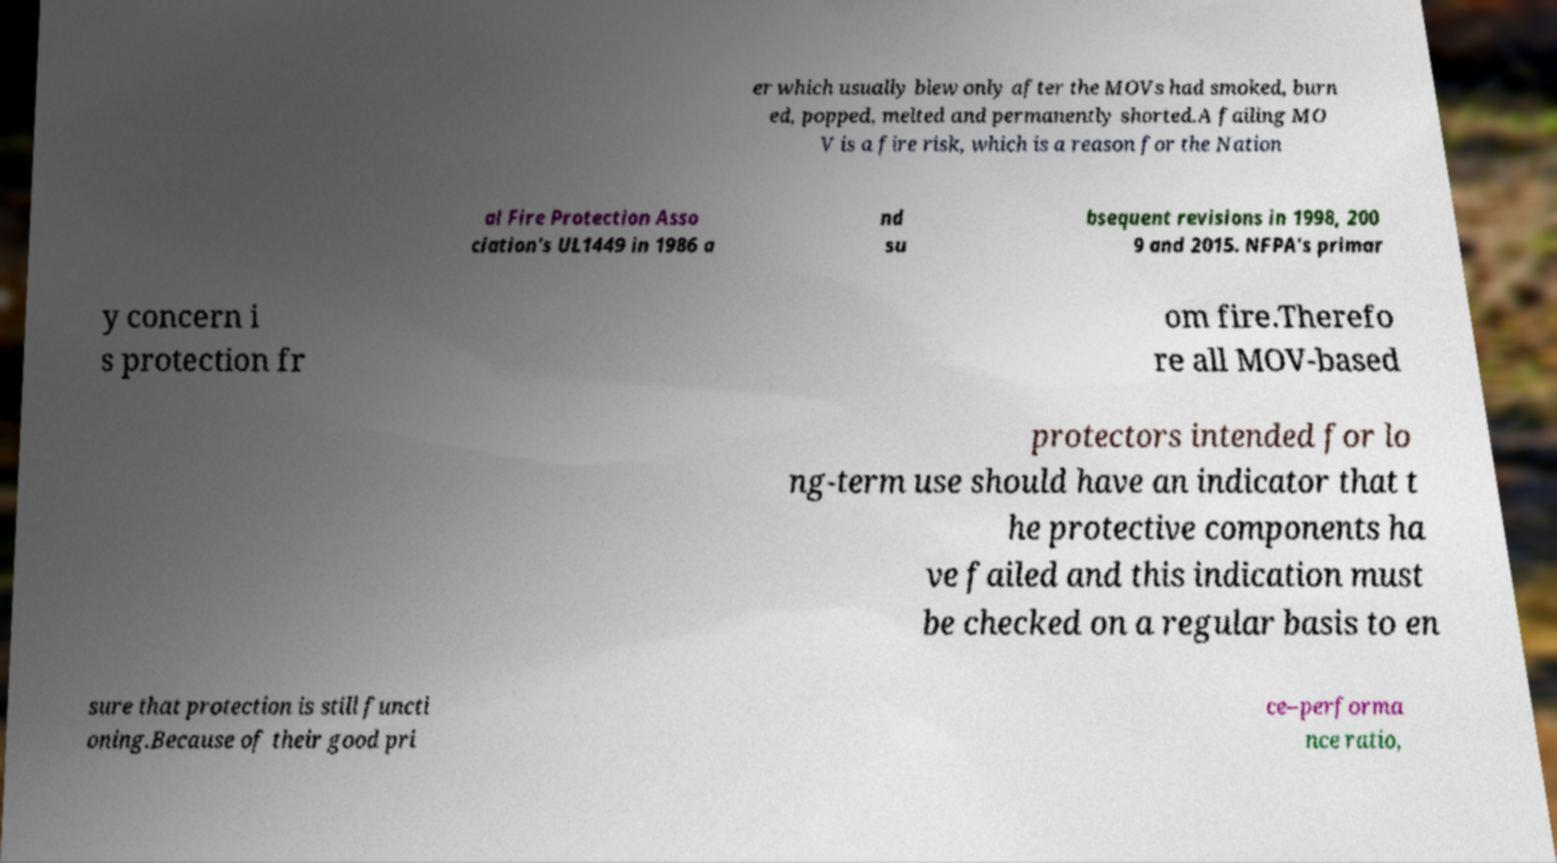Could you extract and type out the text from this image? er which usually blew only after the MOVs had smoked, burn ed, popped, melted and permanently shorted.A failing MO V is a fire risk, which is a reason for the Nation al Fire Protection Asso ciation's UL1449 in 1986 a nd su bsequent revisions in 1998, 200 9 and 2015. NFPA's primar y concern i s protection fr om fire.Therefo re all MOV-based protectors intended for lo ng-term use should have an indicator that t he protective components ha ve failed and this indication must be checked on a regular basis to en sure that protection is still functi oning.Because of their good pri ce–performa nce ratio, 